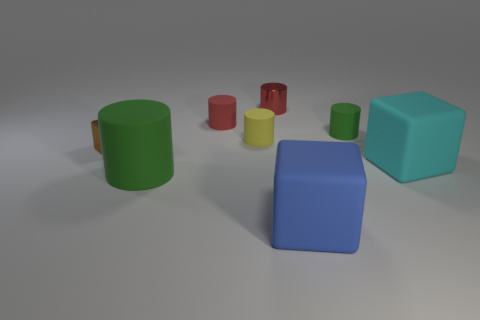Subtract 2 cylinders. How many cylinders are left? 3 Subtract all yellow cylinders. How many cylinders are left? 4 Subtract all small green rubber cylinders. How many cylinders are left? 4 Subtract all cyan cylinders. Subtract all green cubes. How many cylinders are left? 5 Add 2 big rubber cylinders. How many objects exist? 10 Subtract all blocks. How many objects are left? 5 Add 1 tiny green objects. How many tiny green objects exist? 2 Subtract 0 brown cylinders. How many objects are left? 8 Subtract all green cylinders. Subtract all red metallic cylinders. How many objects are left? 5 Add 6 blue matte things. How many blue matte things are left? 7 